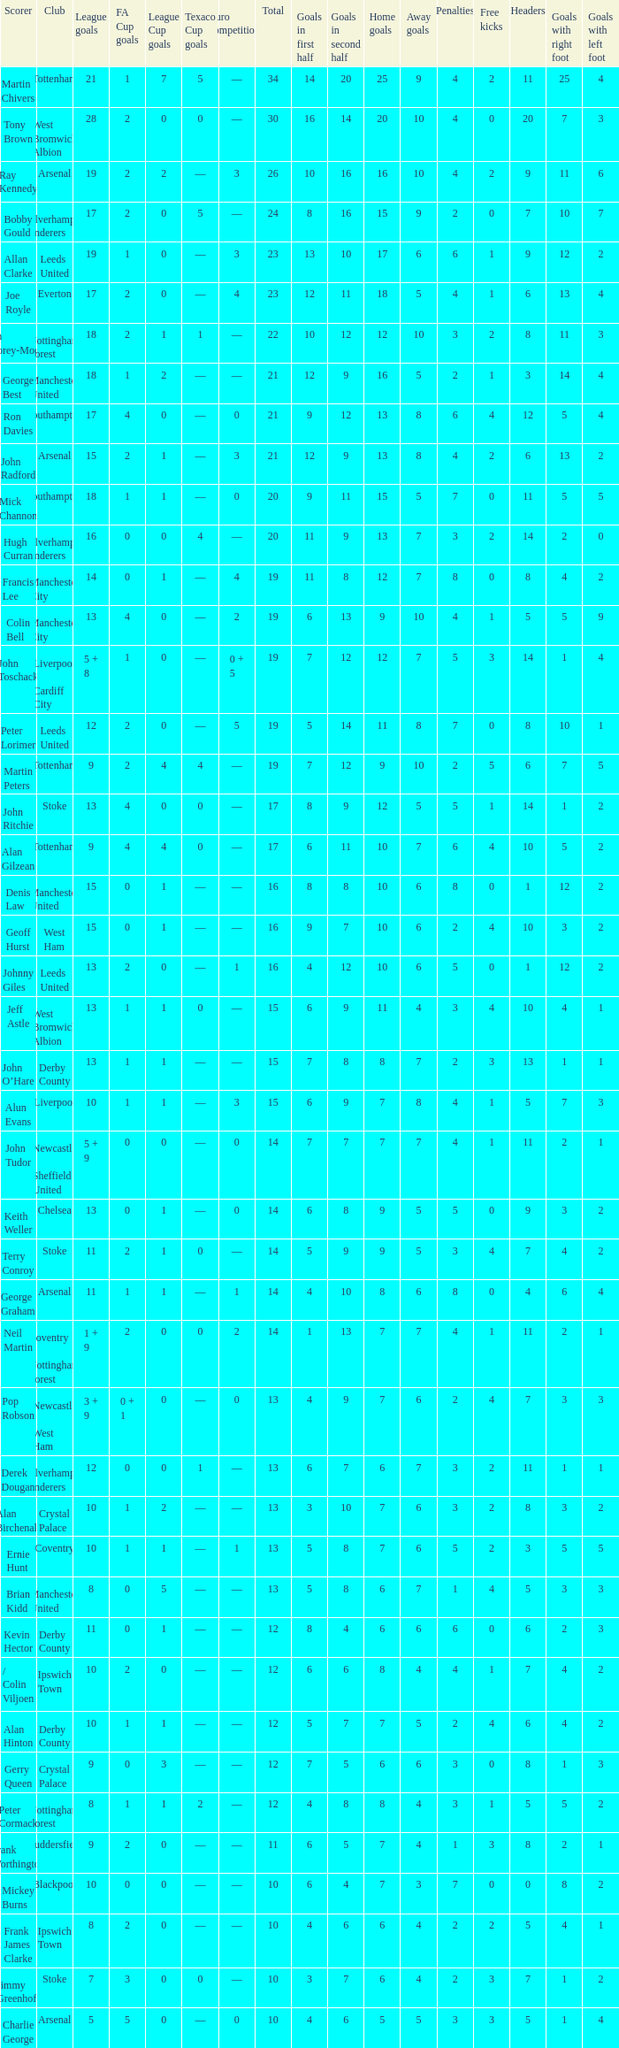What is the total number of Total, when Club is Leeds United, and when League Goals is 13? 1.0. 